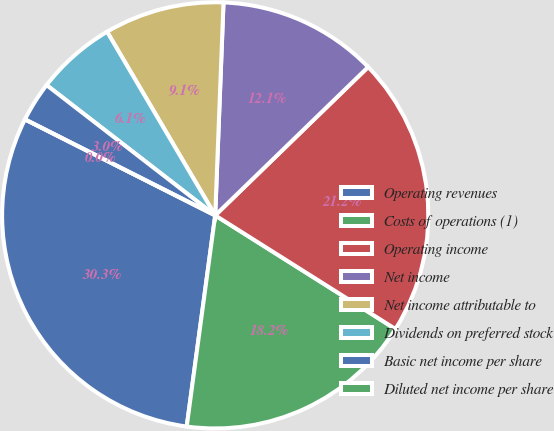Convert chart. <chart><loc_0><loc_0><loc_500><loc_500><pie_chart><fcel>Operating revenues<fcel>Costs of operations (1)<fcel>Operating income<fcel>Net income<fcel>Net income attributable to<fcel>Dividends on preferred stock<fcel>Basic net income per share<fcel>Diluted net income per share<nl><fcel>30.3%<fcel>18.18%<fcel>21.21%<fcel>12.12%<fcel>9.09%<fcel>6.06%<fcel>3.03%<fcel>0.0%<nl></chart> 